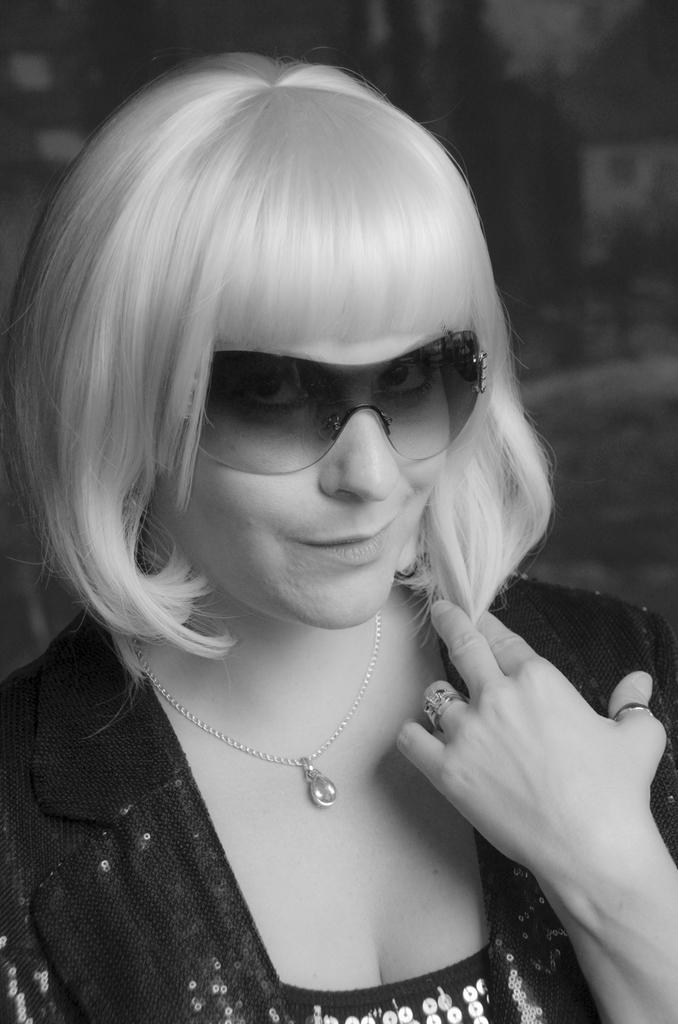What is the color scheme of the image? The image is black and white. Who is present in the image? There is a woman in the image. What is the woman wearing on her face? The woman is wearing goggles. What type of jewelry is the woman wearing? The woman is wearing a locket. Can you tell me how many zebras are present in the image? There are no zebras present in the image; it features a woman wearing goggles and a locket. What type of root is visible in the image? There is no root visible in the image. 